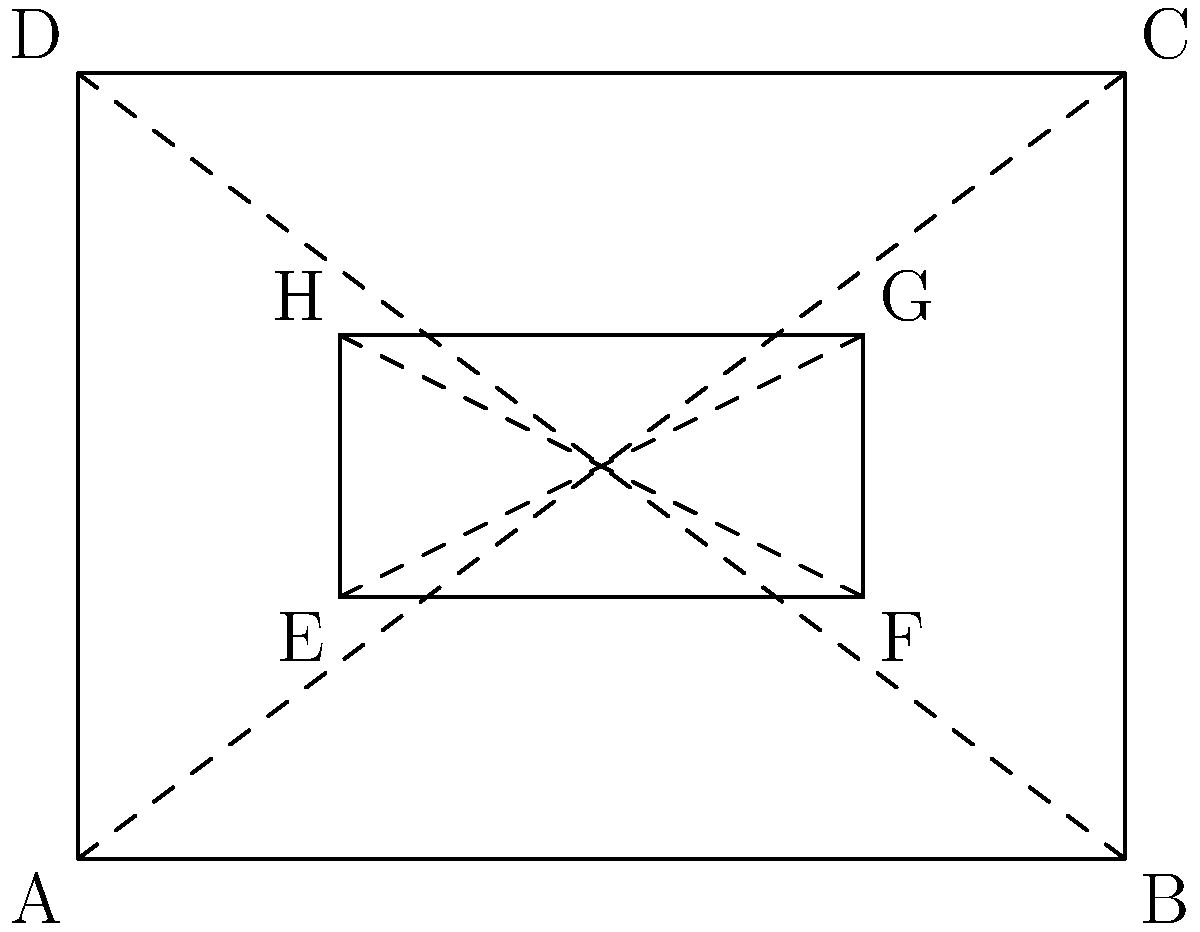In the classic 90s game "Tetris," the playing field is often represented as a rectangular grid. The diagram above shows two rectangles ABCD and EFGH. If these rectangles represent different game screens, what is the minimum number of congruent triangles formed by the diagonals that you need to prove the rectangles are similar? To prove that rectangles ABCD and EFGH are similar, we need to follow these steps:

1. Recall that two rectangles are similar if they have the same shape but possibly different sizes.

2. For rectangles to be similar, their corresponding angles must be congruent (which is always true for rectangles as they all have 90° angles), and their corresponding sides must be proportional.

3. In each rectangle, the diagonals divide it into four triangles:
   - In ABCD: ABO, BCO, CDO, and DAO (where O is the intersection of the diagonals)
   - In EFGH: EFP, FGP, GHP, and HEP (where P is the intersection of the diagonals)

4. If we can prove that one triangle in ABCD is similar to the corresponding triangle in EFGH, it will be sufficient to prove that the rectangles are similar. This is because:
   - All triangles formed by the diagonals in a rectangle are congruent to each other.
   - If one pair of corresponding triangles is similar, then all pairs will be similar.
   - Similar triangles will ensure that the side ratios of the rectangles are the same.

5. Therefore, we only need to prove that one triangle from ABCD (e.g., ABO) is similar to its corresponding triangle in EFGH (e.g., EFP).

6. To prove these triangles are similar, we need to show they are congruent, as congruent triangles are always similar.

Thus, the minimum number of congruent triangles we need to prove is 1.
Answer: 1 